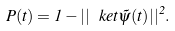Convert formula to latex. <formula><loc_0><loc_0><loc_500><loc_500>P ( t ) = 1 - | | \, \ k e t { \tilde { \psi } ( t ) } | | ^ { 2 } .</formula> 